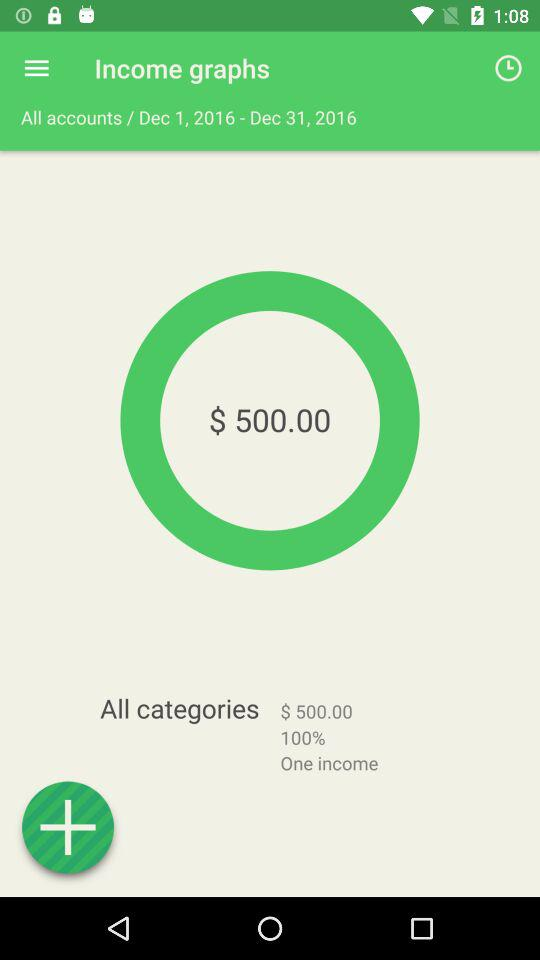What is the total amount of income for all accounts?
Answer the question using a single word or phrase. $500.00 